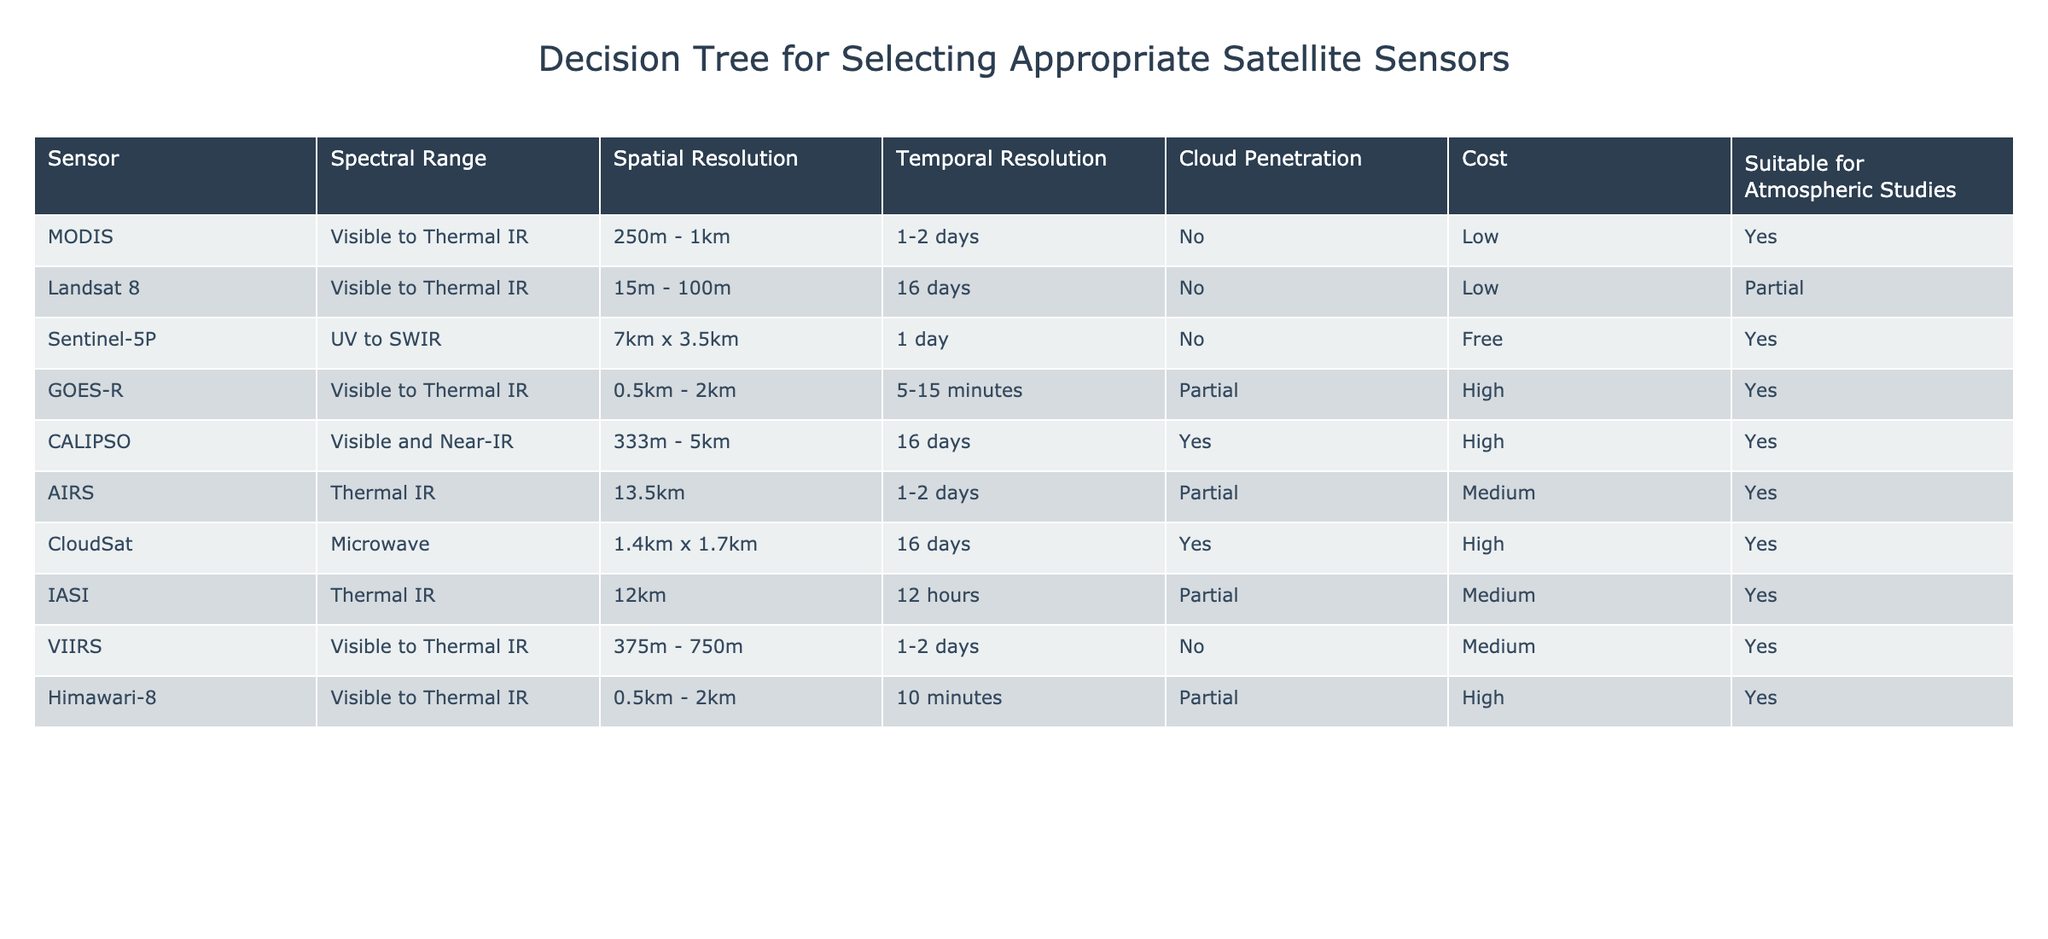What is the spatial resolution of Sentinel-5P? In the table, I can find the row corresponding to Sentinel-5P, which indicates that its spatial resolution is 7 km x 3.5 km.
Answer: 7 km x 3.5 km Which sensors have a cloud penetration capability? By checking the column for Cloud Penetration, I can see that CALIPSO, AIRS, CloudSat, and IASI have a 'Yes' indicating they can penetrate clouds.
Answer: CALIPSO, AIRS, CloudSat, IASI How many sensors are suitable for atmospheric studies? Looking at the column titled "Suitable for Atmospheric Studies", I count the 'Yes' responses. The suitable sensors are MODIS, Sentinel-5P, GOES-R, CALIPSO, AIRS, CloudSat, IASI, VIIRS, and Himawari-8, totaling 8 sensors.
Answer: 8 sensors Which sensor has the highest temporal resolution? I need to compare the temporal resolution across all sensors. The GOES-R sensor has a temporal resolution of 5-15 minutes, which is the highest when compared to others listed in the table.
Answer: GOES-R What is the average spatial resolution of sensors suitable for atmospheric studies? First, I identify the suitable sensors: MODIS (500m), Sentinel-5P (7km x 3.5km), GOES-R (1km), CALIPSO (2.0km), AIRS (13.5km), CloudSat (1.55km), IASI (12km), VIIRS (562.5m), and Himawari-8 (1.25km). I convert all values to meters and sum them: (500 + 3500 + 1000 + 2000 + 13500 + 1400 + 12000 + 562.5 + 1250) = 91812.5. There are 9 sensors, so average = 91812.5 / 9 = 10201.39 meters.
Answer: 10201.39 meters Is Landsat 8 suitable for atmospheric studies? I can look at the row for Landsat 8 and check its status in the "Suitable for Atmospheric Studies" column, which indicates it has a 'Partial' suitability. Therefore, it is not fully suitable.
Answer: No 